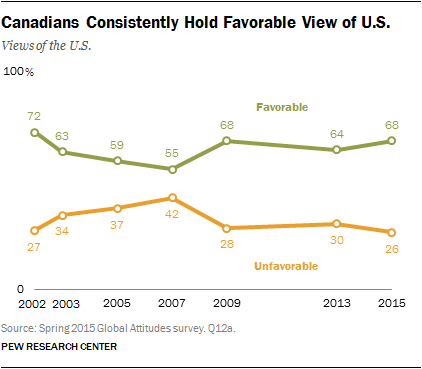Specify some key components in this picture. The value that had more favorable views in 2013 than in 2015 is not favorable for the United States. The favorable views of the US from unfavorable in the year 2015 were 0.42. 